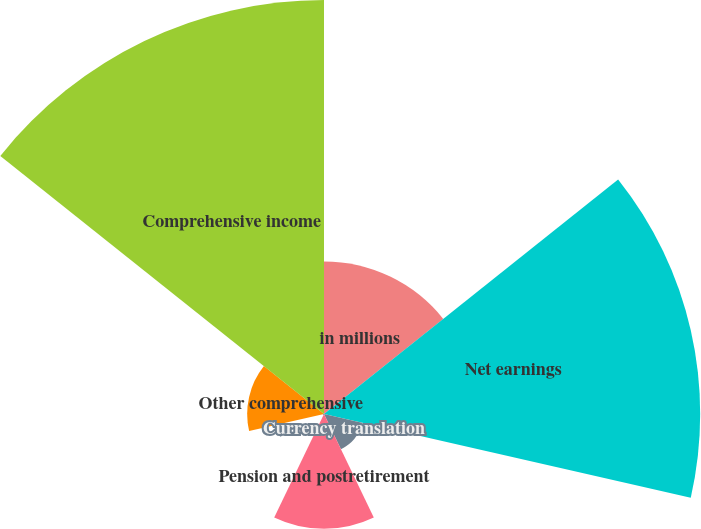<chart> <loc_0><loc_0><loc_500><loc_500><pie_chart><fcel>in millions<fcel>Net earnings<fcel>Currency translation<fcel>Pension and postretirement<fcel>Net unrealized gains/(losses)<fcel>Other comprehensive<fcel>Comprehensive income<nl><fcel>12.99%<fcel>32.03%<fcel>3.32%<fcel>9.77%<fcel>0.1%<fcel>6.54%<fcel>35.25%<nl></chart> 